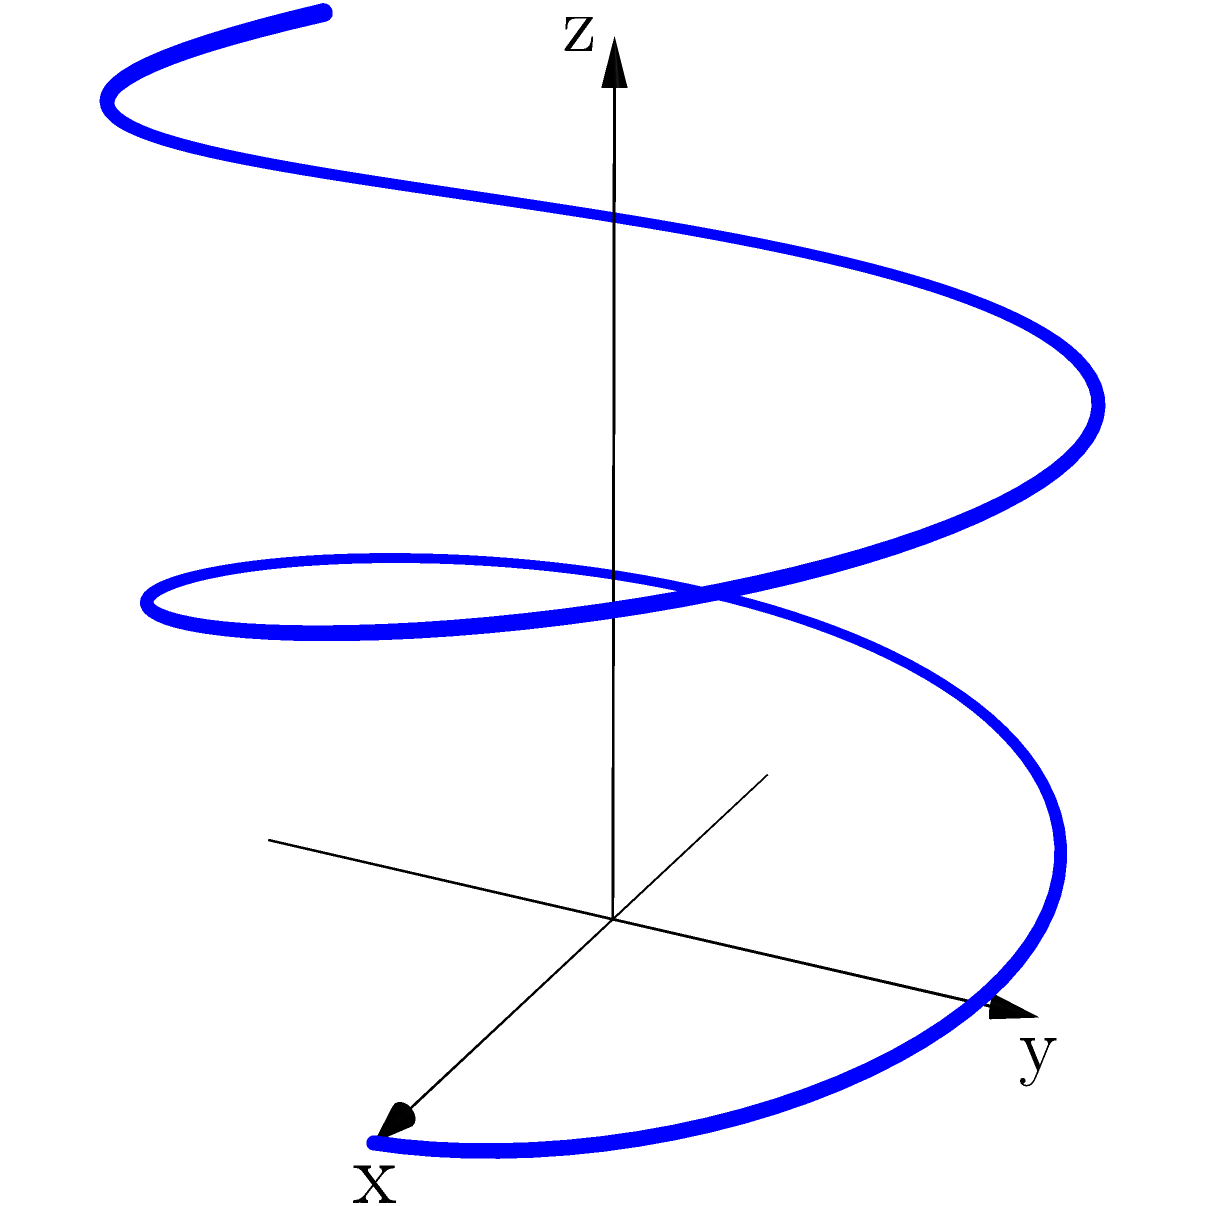In your altered state, you perceive a twisted ribbon-like shape spiraling through space. The shape follows the parametric equations:

$x = 3\cos(2\pi s)$
$y = 3\sin(2\pi s)$
$z = 4s$

Where $0 \leq s \leq 2$. If the ribbon has a constant width of 0.5 units, calculate the surface area of this shape. To calculate the surface area of this twisted ribbon, we'll follow these steps:

1) The surface area of a parametric surface is given by the formula:

   $$A = \int_a^b \sqrt{(\frac{dx}{ds})^2 + (\frac{dy}{ds})^2 + (\frac{dz}{ds})^2} \cdot w \, ds$$

   where $w$ is the width of the ribbon.

2) Let's calculate the derivatives:
   
   $\frac{dx}{ds} = -6\pi\sin(2\pi s)$
   $\frac{dy}{ds} = 6\pi\cos(2\pi s)$
   $\frac{dz}{ds} = 4$

3) Substituting into the formula:

   $$A = \int_0^2 \sqrt{(-6\pi\sin(2\pi s))^2 + (6\pi\cos(2\pi s))^2 + 4^2} \cdot 0.5 \, ds$$

4) Simplify under the square root:

   $$A = \int_0^2 \sqrt{36\pi^2\sin^2(2\pi s) + 36\pi^2\cos^2(2\pi s) + 16} \cdot 0.5 \, ds$$

5) Recall that $\sin^2 + \cos^2 = 1$, so this simplifies to:

   $$A = \int_0^2 \sqrt{36\pi^2 + 16} \cdot 0.5 \, ds = \int_0^2 \sqrt{36\pi^2 + 16} \cdot 0.5 \, ds$$

6) Evaluate the constant under the square root:

   $$A = \int_0^2 \sqrt{355.3} \cdot 0.5 \, ds = \int_0^2 9.43 \cdot 0.5 \, ds$$

7) Integrate:

   $$A = 4.715 \cdot 2 = 9.43$$

Therefore, the surface area of the twisted ribbon is approximately 9.43 square units.
Answer: 9.43 square units 